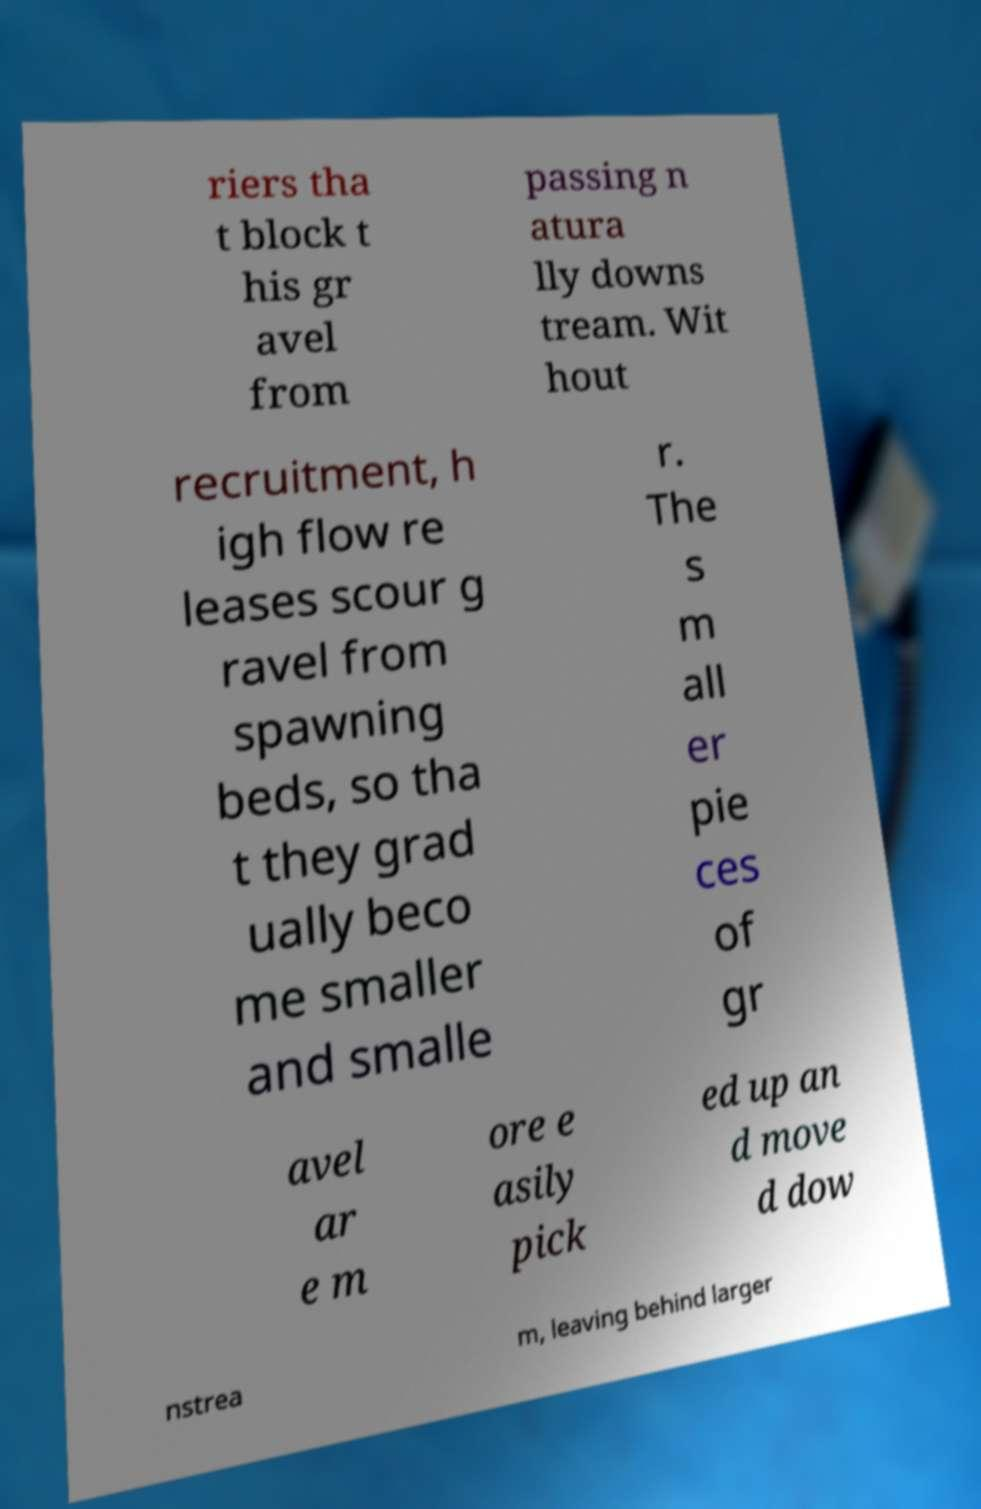For documentation purposes, I need the text within this image transcribed. Could you provide that? riers tha t block t his gr avel from passing n atura lly downs tream. Wit hout recruitment, h igh flow re leases scour g ravel from spawning beds, so tha t they grad ually beco me smaller and smalle r. The s m all er pie ces of gr avel ar e m ore e asily pick ed up an d move d dow nstrea m, leaving behind larger 